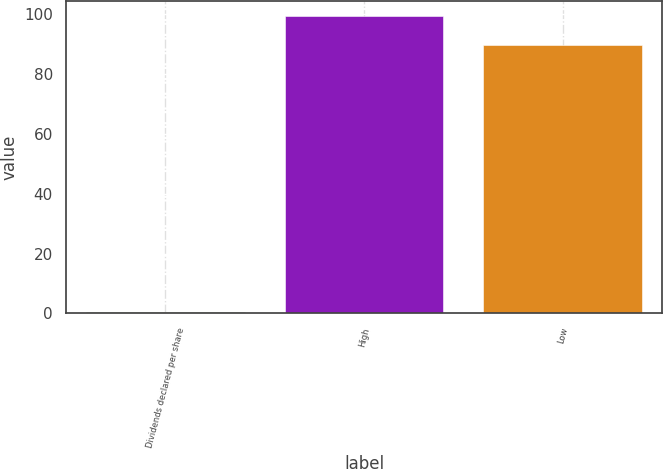Convert chart. <chart><loc_0><loc_0><loc_500><loc_500><bar_chart><fcel>Dividends declared per share<fcel>High<fcel>Low<nl><fcel>0.34<fcel>99.39<fcel>89.81<nl></chart> 